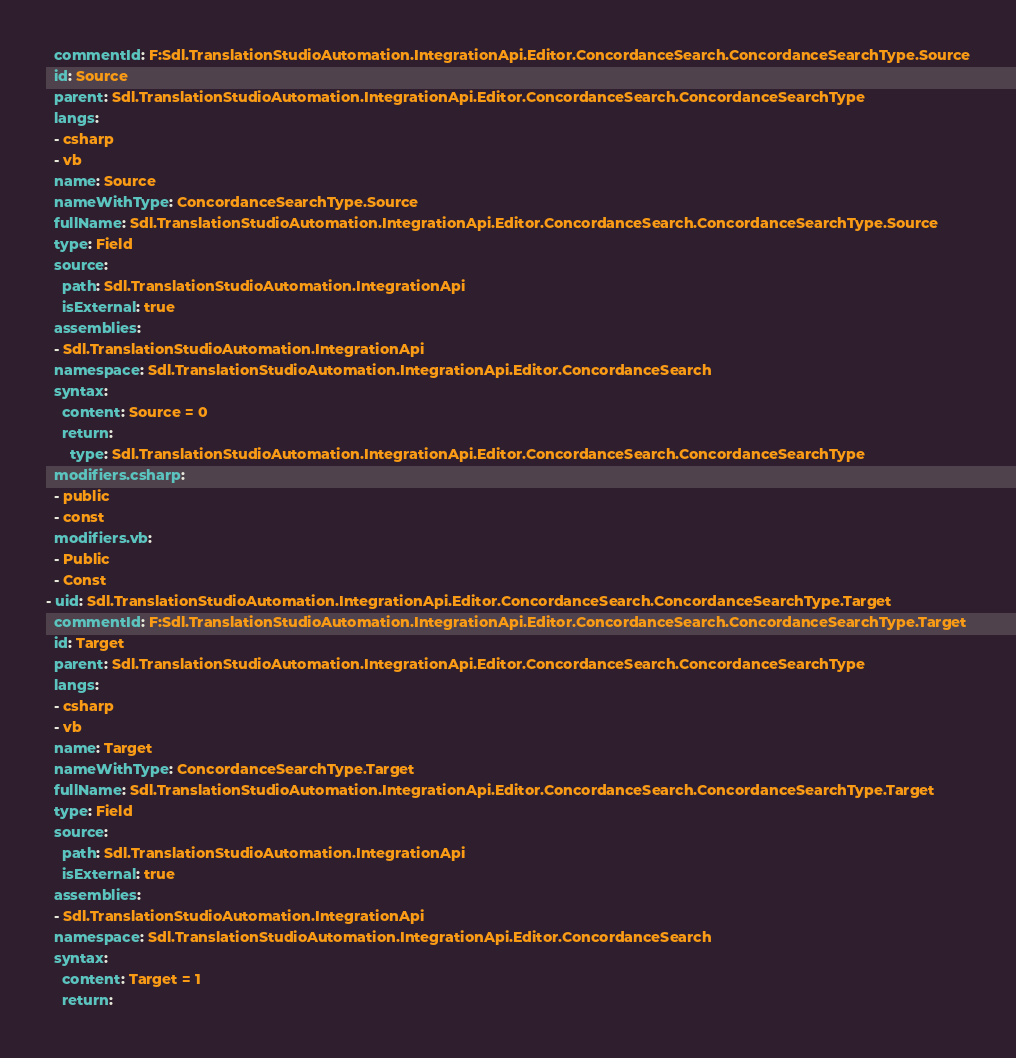Convert code to text. <code><loc_0><loc_0><loc_500><loc_500><_YAML_>  commentId: F:Sdl.TranslationStudioAutomation.IntegrationApi.Editor.ConcordanceSearch.ConcordanceSearchType.Source
  id: Source
  parent: Sdl.TranslationStudioAutomation.IntegrationApi.Editor.ConcordanceSearch.ConcordanceSearchType
  langs:
  - csharp
  - vb
  name: Source
  nameWithType: ConcordanceSearchType.Source
  fullName: Sdl.TranslationStudioAutomation.IntegrationApi.Editor.ConcordanceSearch.ConcordanceSearchType.Source
  type: Field
  source:
    path: Sdl.TranslationStudioAutomation.IntegrationApi
    isExternal: true
  assemblies:
  - Sdl.TranslationStudioAutomation.IntegrationApi
  namespace: Sdl.TranslationStudioAutomation.IntegrationApi.Editor.ConcordanceSearch
  syntax:
    content: Source = 0
    return:
      type: Sdl.TranslationStudioAutomation.IntegrationApi.Editor.ConcordanceSearch.ConcordanceSearchType
  modifiers.csharp:
  - public
  - const
  modifiers.vb:
  - Public
  - Const
- uid: Sdl.TranslationStudioAutomation.IntegrationApi.Editor.ConcordanceSearch.ConcordanceSearchType.Target
  commentId: F:Sdl.TranslationStudioAutomation.IntegrationApi.Editor.ConcordanceSearch.ConcordanceSearchType.Target
  id: Target
  parent: Sdl.TranslationStudioAutomation.IntegrationApi.Editor.ConcordanceSearch.ConcordanceSearchType
  langs:
  - csharp
  - vb
  name: Target
  nameWithType: ConcordanceSearchType.Target
  fullName: Sdl.TranslationStudioAutomation.IntegrationApi.Editor.ConcordanceSearch.ConcordanceSearchType.Target
  type: Field
  source:
    path: Sdl.TranslationStudioAutomation.IntegrationApi
    isExternal: true
  assemblies:
  - Sdl.TranslationStudioAutomation.IntegrationApi
  namespace: Sdl.TranslationStudioAutomation.IntegrationApi.Editor.ConcordanceSearch
  syntax:
    content: Target = 1
    return:</code> 